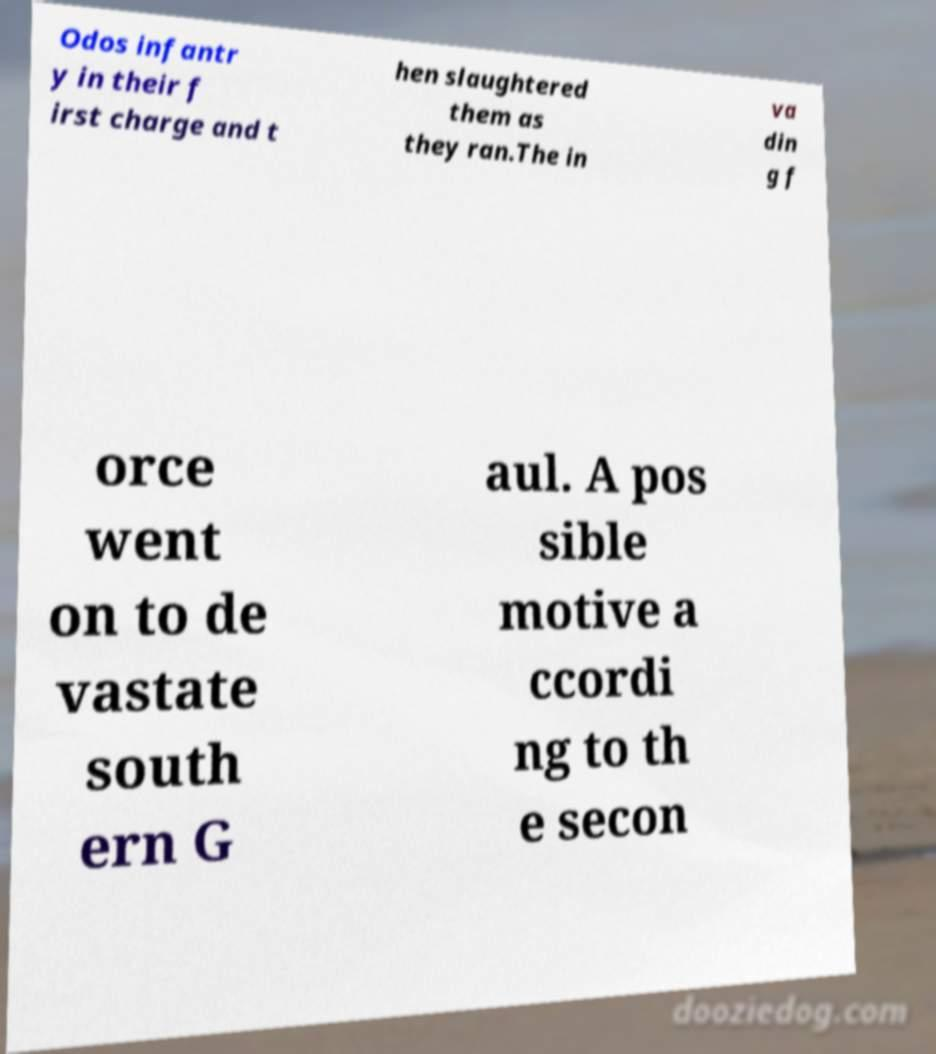There's text embedded in this image that I need extracted. Can you transcribe it verbatim? Odos infantr y in their f irst charge and t hen slaughtered them as they ran.The in va din g f orce went on to de vastate south ern G aul. A pos sible motive a ccordi ng to th e secon 